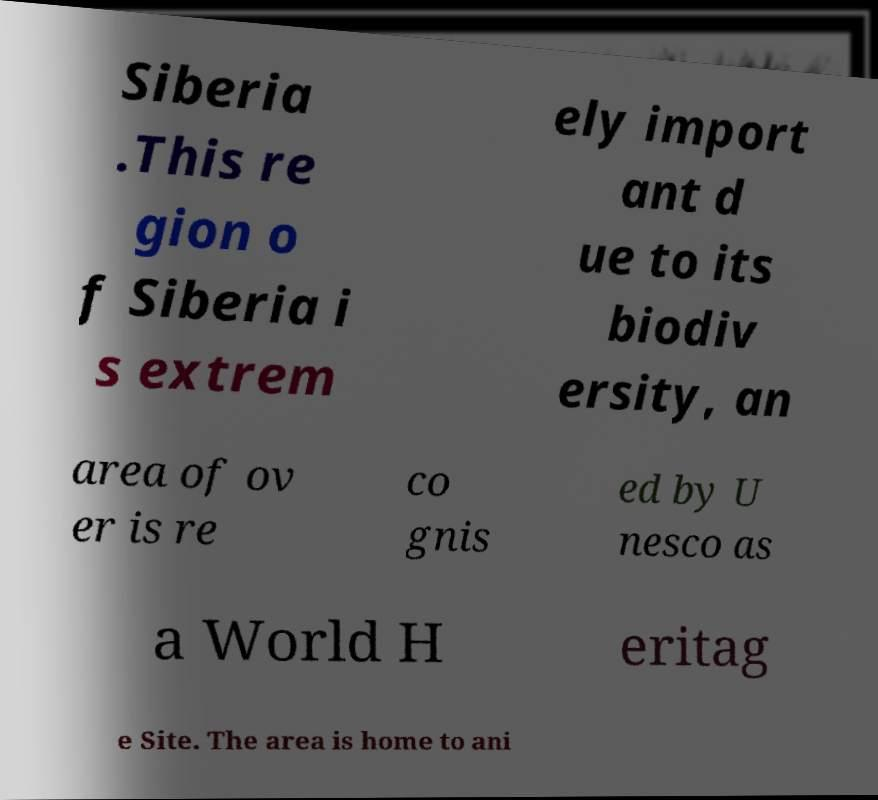Please read and relay the text visible in this image. What does it say? Siberia .This re gion o f Siberia i s extrem ely import ant d ue to its biodiv ersity, an area of ov er is re co gnis ed by U nesco as a World H eritag e Site. The area is home to ani 